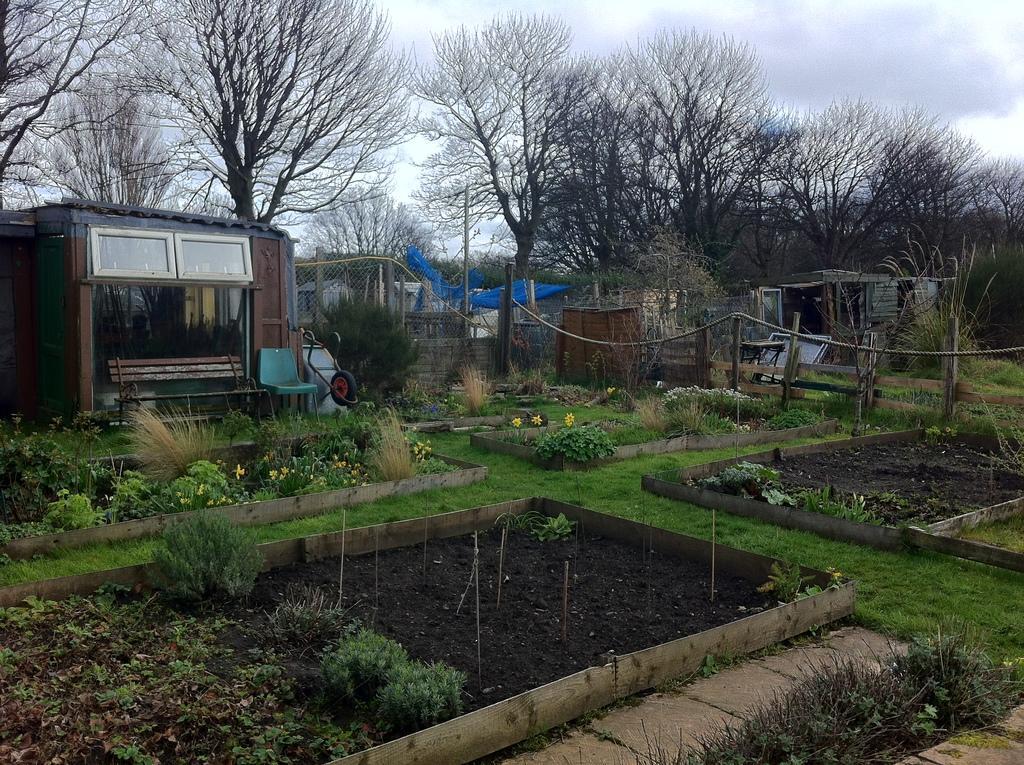Can you describe this image briefly? In the image to the bottom there is a garden area. To the bottom corner of the image there is a rectangular shape area with grass and black soil in it. To the right side of the image there is also a rectangular area with black soil and grass in it. On the ground there is a grass and plants with flowers. In the background there is a room with windows. In front of the room there is a bench and chair. And also there are many trees, fencing. wooden poles with rope and to the top of the image there is a sky. 